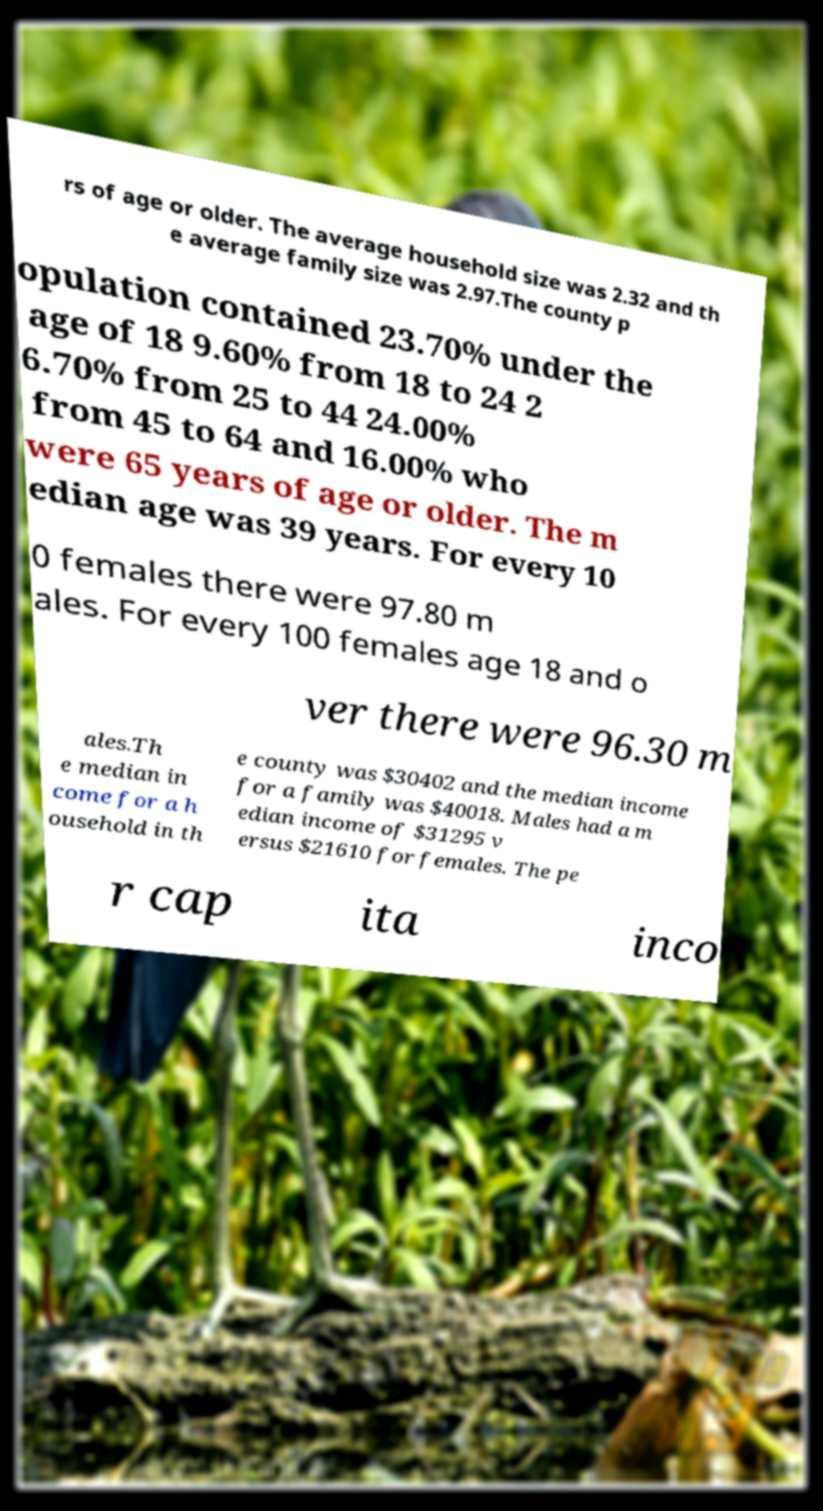Please identify and transcribe the text found in this image. rs of age or older. The average household size was 2.32 and th e average family size was 2.97.The county p opulation contained 23.70% under the age of 18 9.60% from 18 to 24 2 6.70% from 25 to 44 24.00% from 45 to 64 and 16.00% who were 65 years of age or older. The m edian age was 39 years. For every 10 0 females there were 97.80 m ales. For every 100 females age 18 and o ver there were 96.30 m ales.Th e median in come for a h ousehold in th e county was $30402 and the median income for a family was $40018. Males had a m edian income of $31295 v ersus $21610 for females. The pe r cap ita inco 